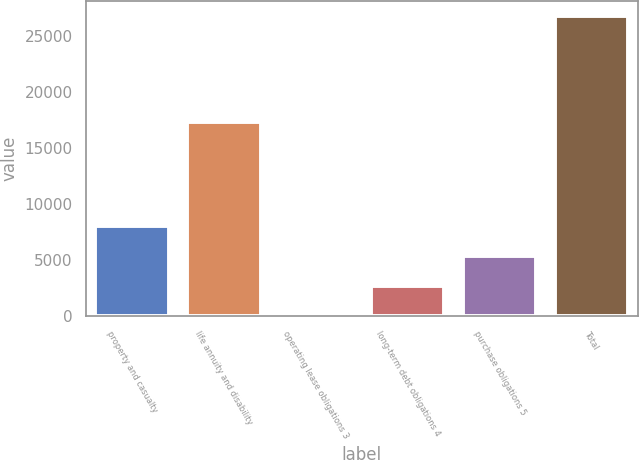Convert chart. <chart><loc_0><loc_0><loc_500><loc_500><bar_chart><fcel>property and casualty<fcel>life annuity and disability<fcel>operating lease obligations 3<fcel>long-term debt obligations 4<fcel>purchase obligations 5<fcel>Total<nl><fcel>8079.3<fcel>17318<fcel>42<fcel>2721.1<fcel>5400.2<fcel>26833<nl></chart> 